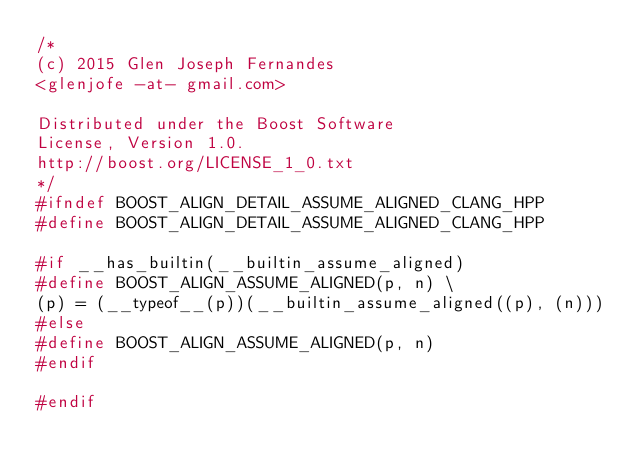<code> <loc_0><loc_0><loc_500><loc_500><_C++_>/*
(c) 2015 Glen Joseph Fernandes
<glenjofe -at- gmail.com>

Distributed under the Boost Software
License, Version 1.0.
http://boost.org/LICENSE_1_0.txt
*/
#ifndef BOOST_ALIGN_DETAIL_ASSUME_ALIGNED_CLANG_HPP
#define BOOST_ALIGN_DETAIL_ASSUME_ALIGNED_CLANG_HPP

#if __has_builtin(__builtin_assume_aligned)
#define BOOST_ALIGN_ASSUME_ALIGNED(p, n) \
(p) = (__typeof__(p))(__builtin_assume_aligned((p), (n)))
#else
#define BOOST_ALIGN_ASSUME_ALIGNED(p, n)
#endif

#endif
</code> 